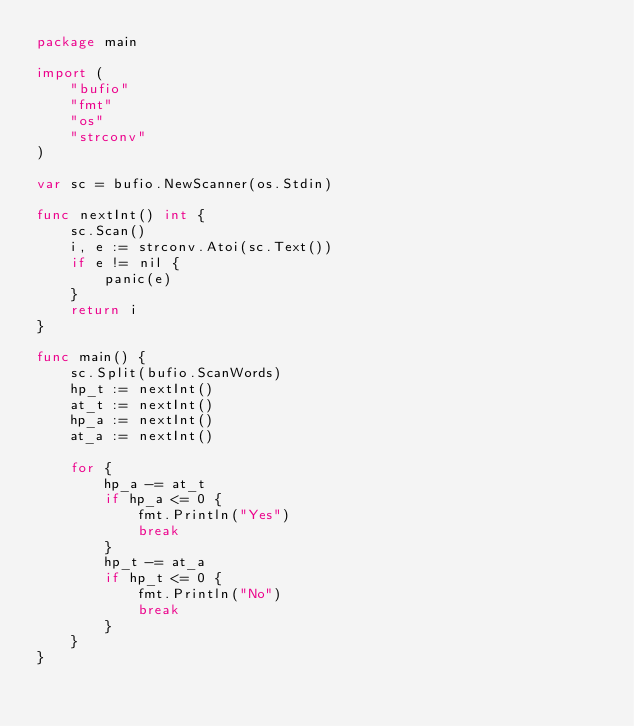<code> <loc_0><loc_0><loc_500><loc_500><_Go_>package main

import (
	"bufio"
	"fmt"
	"os"
	"strconv"
)

var sc = bufio.NewScanner(os.Stdin)

func nextInt() int {
	sc.Scan()
	i, e := strconv.Atoi(sc.Text())
	if e != nil {
		panic(e)
	}
	return i
}

func main() {
	sc.Split(bufio.ScanWords)
	hp_t := nextInt()
	at_t := nextInt()
	hp_a := nextInt()
	at_a := nextInt()

	for {
		hp_a -= at_t
		if hp_a <= 0 {
			fmt.Println("Yes")
			break
		}
		hp_t -= at_a
		if hp_t <= 0 {
			fmt.Println("No")
			break
		}
	}
}
</code> 